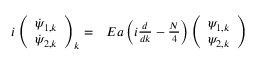<formula> <loc_0><loc_0><loc_500><loc_500>\begin{array} { r l } { i \left ( \begin{array} { c } { \dot { \psi } _ { 1 , k } } \\ { \dot { \psi } _ { 2 , k } } \end{array} \right ) _ { k } = } & E a \left ( i \frac { d } { d k } - \frac { N } { 4 } \right ) \left ( \begin{array} { c } { \psi _ { 1 , k } } \\ { \psi _ { 2 , k } } \end{array} \right ) } \end{array}</formula> 